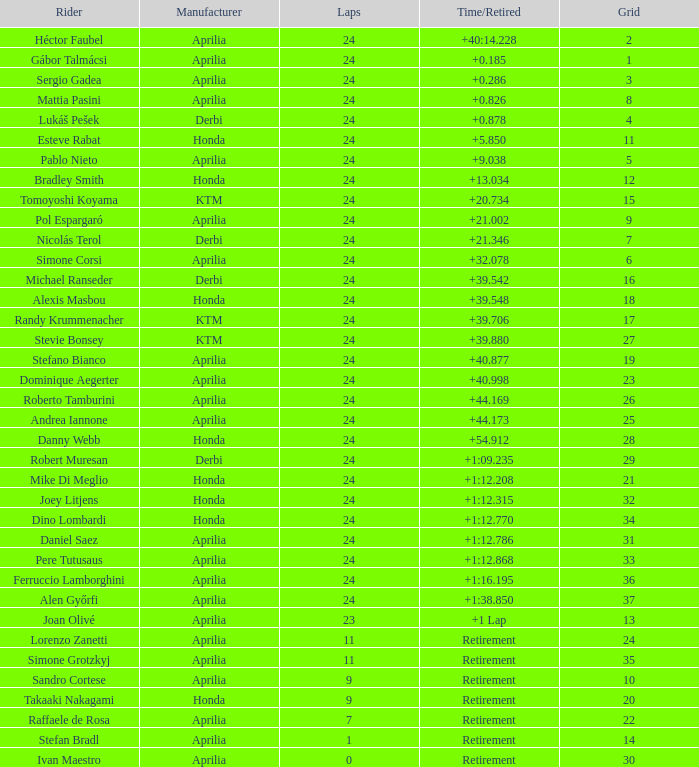Who is the manufacturer of the motorcycle that achieved 24 laps and 9 grids? Aprilia. 